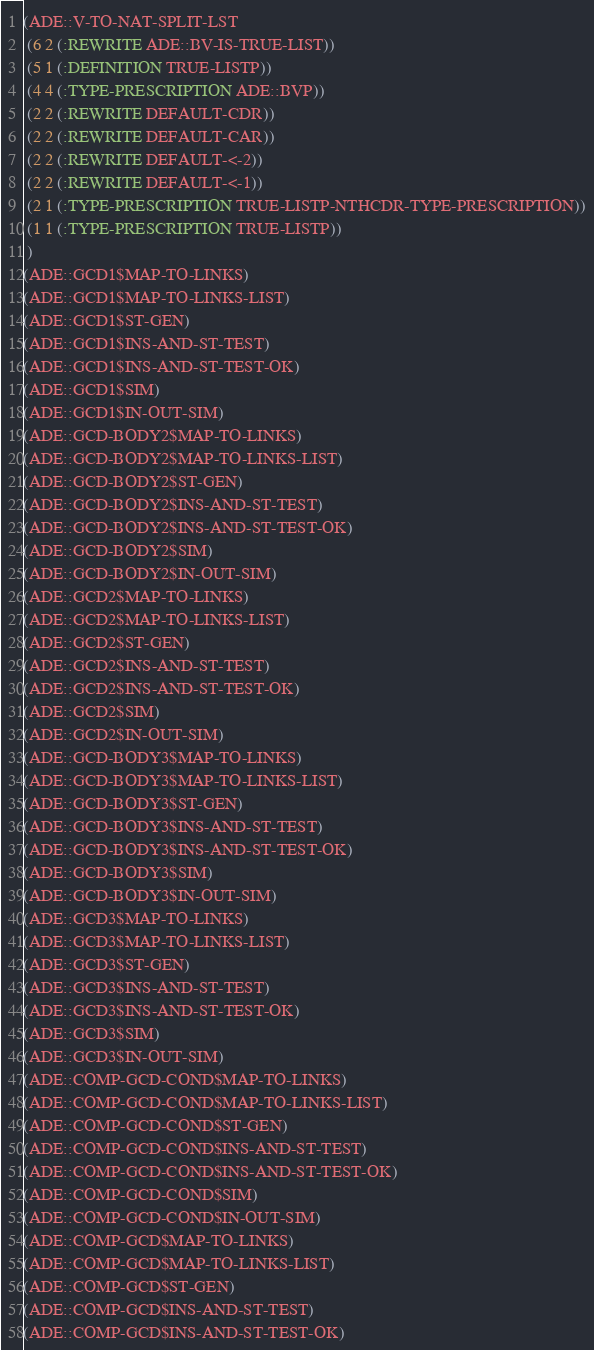<code> <loc_0><loc_0><loc_500><loc_500><_Lisp_>(ADE::V-TO-NAT-SPLIT-LST
 (6 2 (:REWRITE ADE::BV-IS-TRUE-LIST))
 (5 1 (:DEFINITION TRUE-LISTP))
 (4 4 (:TYPE-PRESCRIPTION ADE::BVP))
 (2 2 (:REWRITE DEFAULT-CDR))
 (2 2 (:REWRITE DEFAULT-CAR))
 (2 2 (:REWRITE DEFAULT-<-2))
 (2 2 (:REWRITE DEFAULT-<-1))
 (2 1 (:TYPE-PRESCRIPTION TRUE-LISTP-NTHCDR-TYPE-PRESCRIPTION))
 (1 1 (:TYPE-PRESCRIPTION TRUE-LISTP))
 )
(ADE::GCD1$MAP-TO-LINKS)
(ADE::GCD1$MAP-TO-LINKS-LIST)
(ADE::GCD1$ST-GEN)
(ADE::GCD1$INS-AND-ST-TEST)
(ADE::GCD1$INS-AND-ST-TEST-OK)
(ADE::GCD1$SIM)
(ADE::GCD1$IN-OUT-SIM)
(ADE::GCD-BODY2$MAP-TO-LINKS)
(ADE::GCD-BODY2$MAP-TO-LINKS-LIST)
(ADE::GCD-BODY2$ST-GEN)
(ADE::GCD-BODY2$INS-AND-ST-TEST)
(ADE::GCD-BODY2$INS-AND-ST-TEST-OK)
(ADE::GCD-BODY2$SIM)
(ADE::GCD-BODY2$IN-OUT-SIM)
(ADE::GCD2$MAP-TO-LINKS)
(ADE::GCD2$MAP-TO-LINKS-LIST)
(ADE::GCD2$ST-GEN)
(ADE::GCD2$INS-AND-ST-TEST)
(ADE::GCD2$INS-AND-ST-TEST-OK)
(ADE::GCD2$SIM)
(ADE::GCD2$IN-OUT-SIM)
(ADE::GCD-BODY3$MAP-TO-LINKS)
(ADE::GCD-BODY3$MAP-TO-LINKS-LIST)
(ADE::GCD-BODY3$ST-GEN)
(ADE::GCD-BODY3$INS-AND-ST-TEST)
(ADE::GCD-BODY3$INS-AND-ST-TEST-OK)
(ADE::GCD-BODY3$SIM)
(ADE::GCD-BODY3$IN-OUT-SIM)
(ADE::GCD3$MAP-TO-LINKS)
(ADE::GCD3$MAP-TO-LINKS-LIST)
(ADE::GCD3$ST-GEN)
(ADE::GCD3$INS-AND-ST-TEST)
(ADE::GCD3$INS-AND-ST-TEST-OK)
(ADE::GCD3$SIM)
(ADE::GCD3$IN-OUT-SIM)
(ADE::COMP-GCD-COND$MAP-TO-LINKS)
(ADE::COMP-GCD-COND$MAP-TO-LINKS-LIST)
(ADE::COMP-GCD-COND$ST-GEN)
(ADE::COMP-GCD-COND$INS-AND-ST-TEST)
(ADE::COMP-GCD-COND$INS-AND-ST-TEST-OK)
(ADE::COMP-GCD-COND$SIM)
(ADE::COMP-GCD-COND$IN-OUT-SIM)
(ADE::COMP-GCD$MAP-TO-LINKS)
(ADE::COMP-GCD$MAP-TO-LINKS-LIST)
(ADE::COMP-GCD$ST-GEN)
(ADE::COMP-GCD$INS-AND-ST-TEST)
(ADE::COMP-GCD$INS-AND-ST-TEST-OK)</code> 